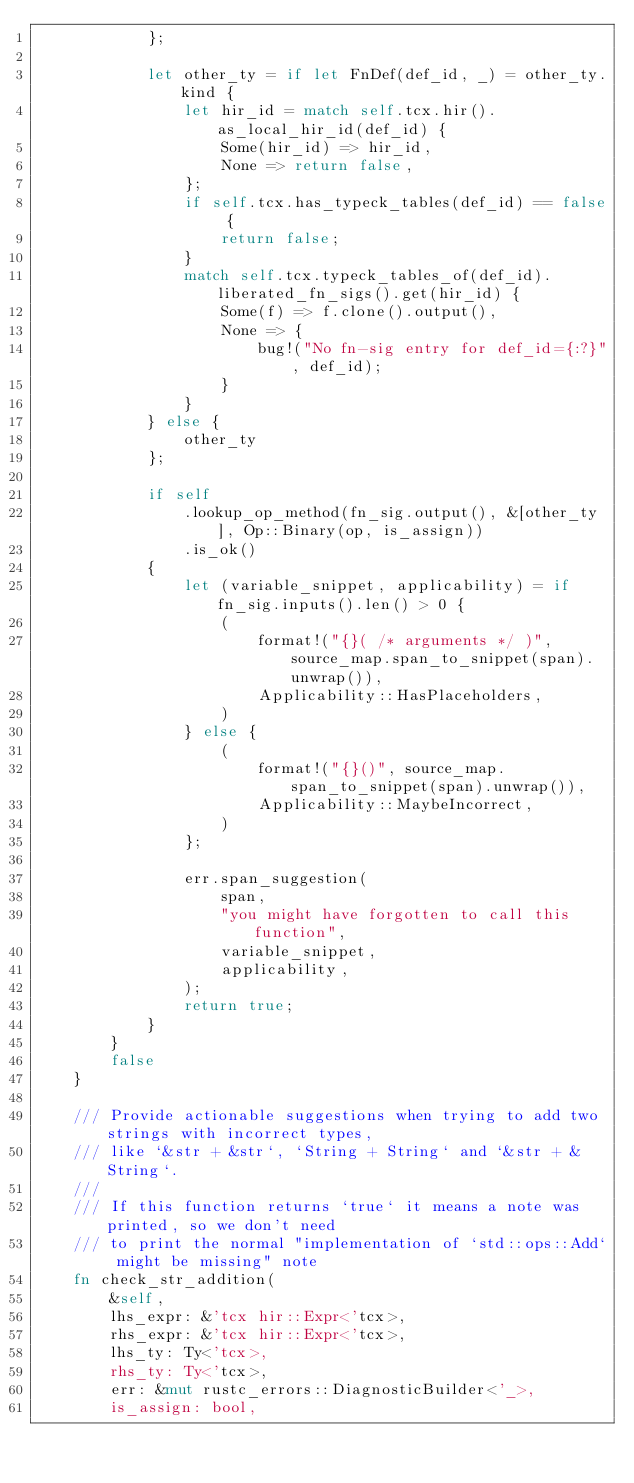Convert code to text. <code><loc_0><loc_0><loc_500><loc_500><_Rust_>            };

            let other_ty = if let FnDef(def_id, _) = other_ty.kind {
                let hir_id = match self.tcx.hir().as_local_hir_id(def_id) {
                    Some(hir_id) => hir_id,
                    None => return false,
                };
                if self.tcx.has_typeck_tables(def_id) == false {
                    return false;
                }
                match self.tcx.typeck_tables_of(def_id).liberated_fn_sigs().get(hir_id) {
                    Some(f) => f.clone().output(),
                    None => {
                        bug!("No fn-sig entry for def_id={:?}", def_id);
                    }
                }
            } else {
                other_ty
            };

            if self
                .lookup_op_method(fn_sig.output(), &[other_ty], Op::Binary(op, is_assign))
                .is_ok()
            {
                let (variable_snippet, applicability) = if fn_sig.inputs().len() > 0 {
                    (
                        format!("{}( /* arguments */ )", source_map.span_to_snippet(span).unwrap()),
                        Applicability::HasPlaceholders,
                    )
                } else {
                    (
                        format!("{}()", source_map.span_to_snippet(span).unwrap()),
                        Applicability::MaybeIncorrect,
                    )
                };

                err.span_suggestion(
                    span,
                    "you might have forgotten to call this function",
                    variable_snippet,
                    applicability,
                );
                return true;
            }
        }
        false
    }

    /// Provide actionable suggestions when trying to add two strings with incorrect types,
    /// like `&str + &str`, `String + String` and `&str + &String`.
    ///
    /// If this function returns `true` it means a note was printed, so we don't need
    /// to print the normal "implementation of `std::ops::Add` might be missing" note
    fn check_str_addition(
        &self,
        lhs_expr: &'tcx hir::Expr<'tcx>,
        rhs_expr: &'tcx hir::Expr<'tcx>,
        lhs_ty: Ty<'tcx>,
        rhs_ty: Ty<'tcx>,
        err: &mut rustc_errors::DiagnosticBuilder<'_>,
        is_assign: bool,</code> 